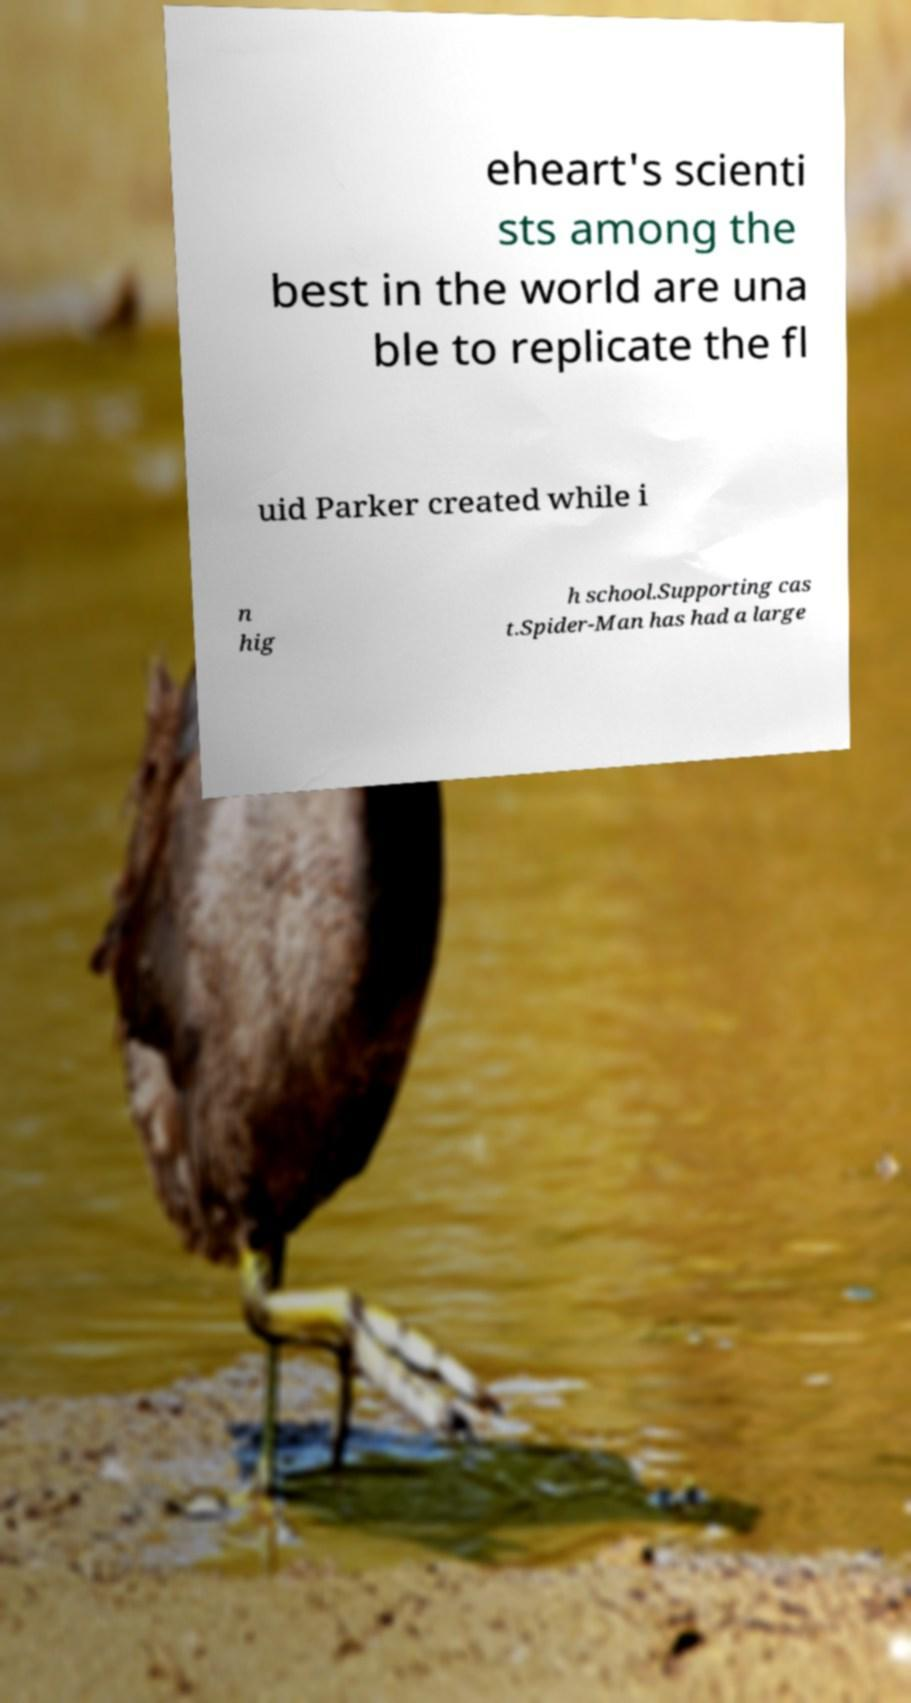Could you assist in decoding the text presented in this image and type it out clearly? eheart's scienti sts among the best in the world are una ble to replicate the fl uid Parker created while i n hig h school.Supporting cas t.Spider-Man has had a large 